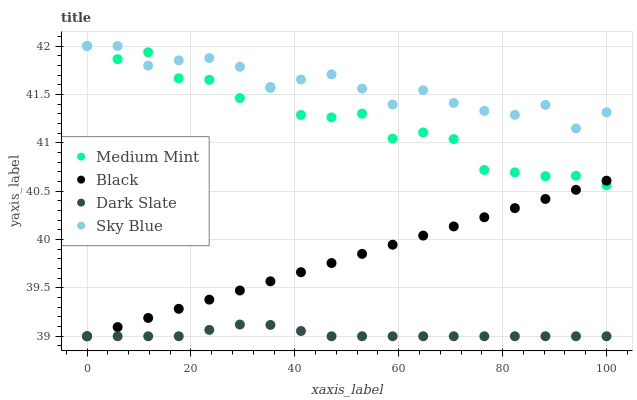Does Dark Slate have the minimum area under the curve?
Answer yes or no. Yes. Does Sky Blue have the maximum area under the curve?
Answer yes or no. Yes. Does Black have the minimum area under the curve?
Answer yes or no. No. Does Black have the maximum area under the curve?
Answer yes or no. No. Is Black the smoothest?
Answer yes or no. Yes. Is Medium Mint the roughest?
Answer yes or no. Yes. Is Dark Slate the smoothest?
Answer yes or no. No. Is Dark Slate the roughest?
Answer yes or no. No. Does Dark Slate have the lowest value?
Answer yes or no. Yes. Does Sky Blue have the lowest value?
Answer yes or no. No. Does Sky Blue have the highest value?
Answer yes or no. Yes. Does Black have the highest value?
Answer yes or no. No. Is Black less than Sky Blue?
Answer yes or no. Yes. Is Medium Mint greater than Dark Slate?
Answer yes or no. Yes. Does Black intersect Dark Slate?
Answer yes or no. Yes. Is Black less than Dark Slate?
Answer yes or no. No. Is Black greater than Dark Slate?
Answer yes or no. No. Does Black intersect Sky Blue?
Answer yes or no. No. 